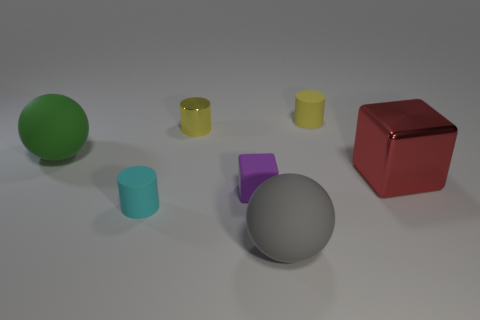Add 1 gray matte objects. How many objects exist? 8 Subtract all blocks. How many objects are left? 5 Subtract 0 purple balls. How many objects are left? 7 Subtract all tiny gray metal objects. Subtract all tiny cyan cylinders. How many objects are left? 6 Add 3 green spheres. How many green spheres are left? 4 Add 7 spheres. How many spheres exist? 9 